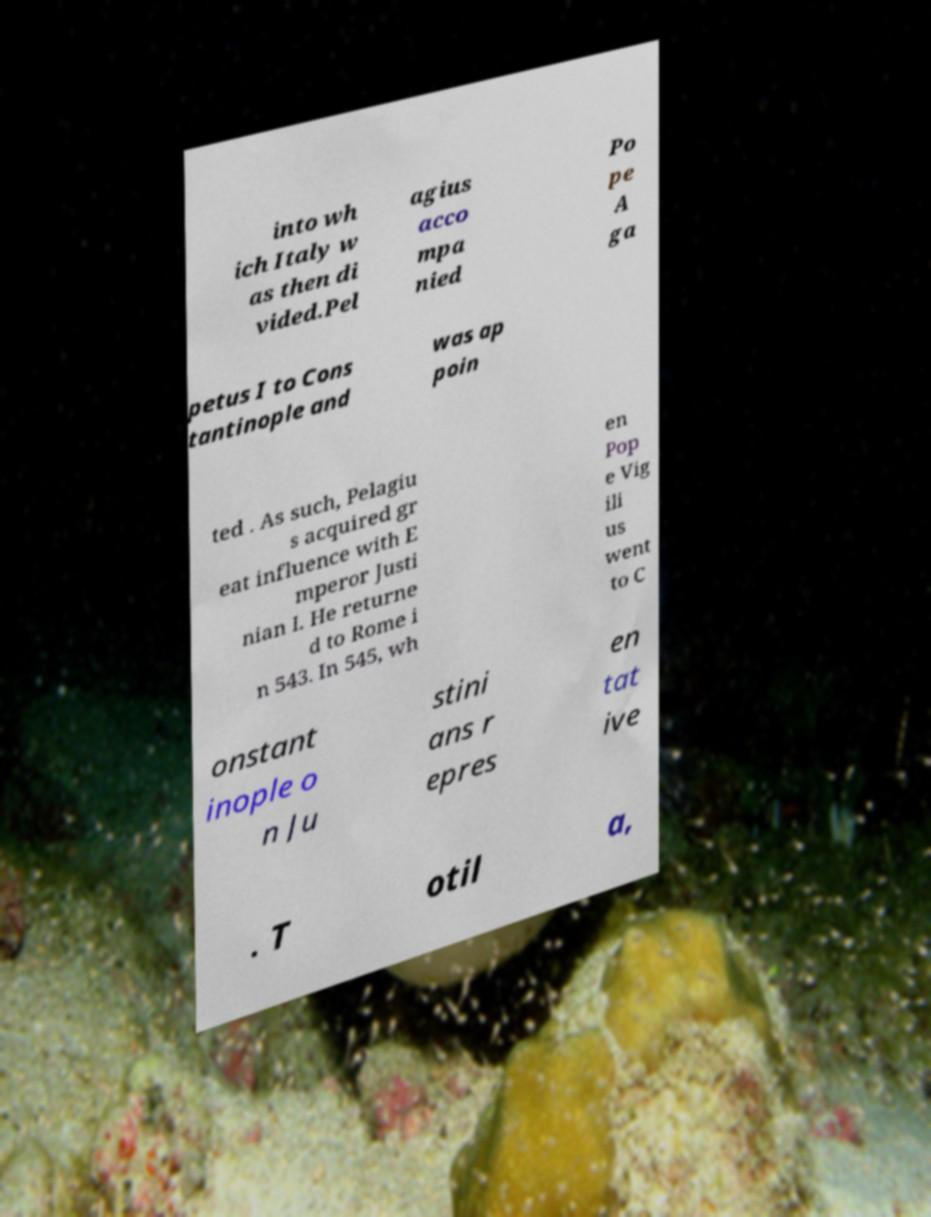Can you accurately transcribe the text from the provided image for me? into wh ich Italy w as then di vided.Pel agius acco mpa nied Po pe A ga petus I to Cons tantinople and was ap poin ted . As such, Pelagiu s acquired gr eat influence with E mperor Justi nian I. He returne d to Rome i n 543. In 545, wh en Pop e Vig ili us went to C onstant inople o n Ju stini ans r epres en tat ive . T otil a, 